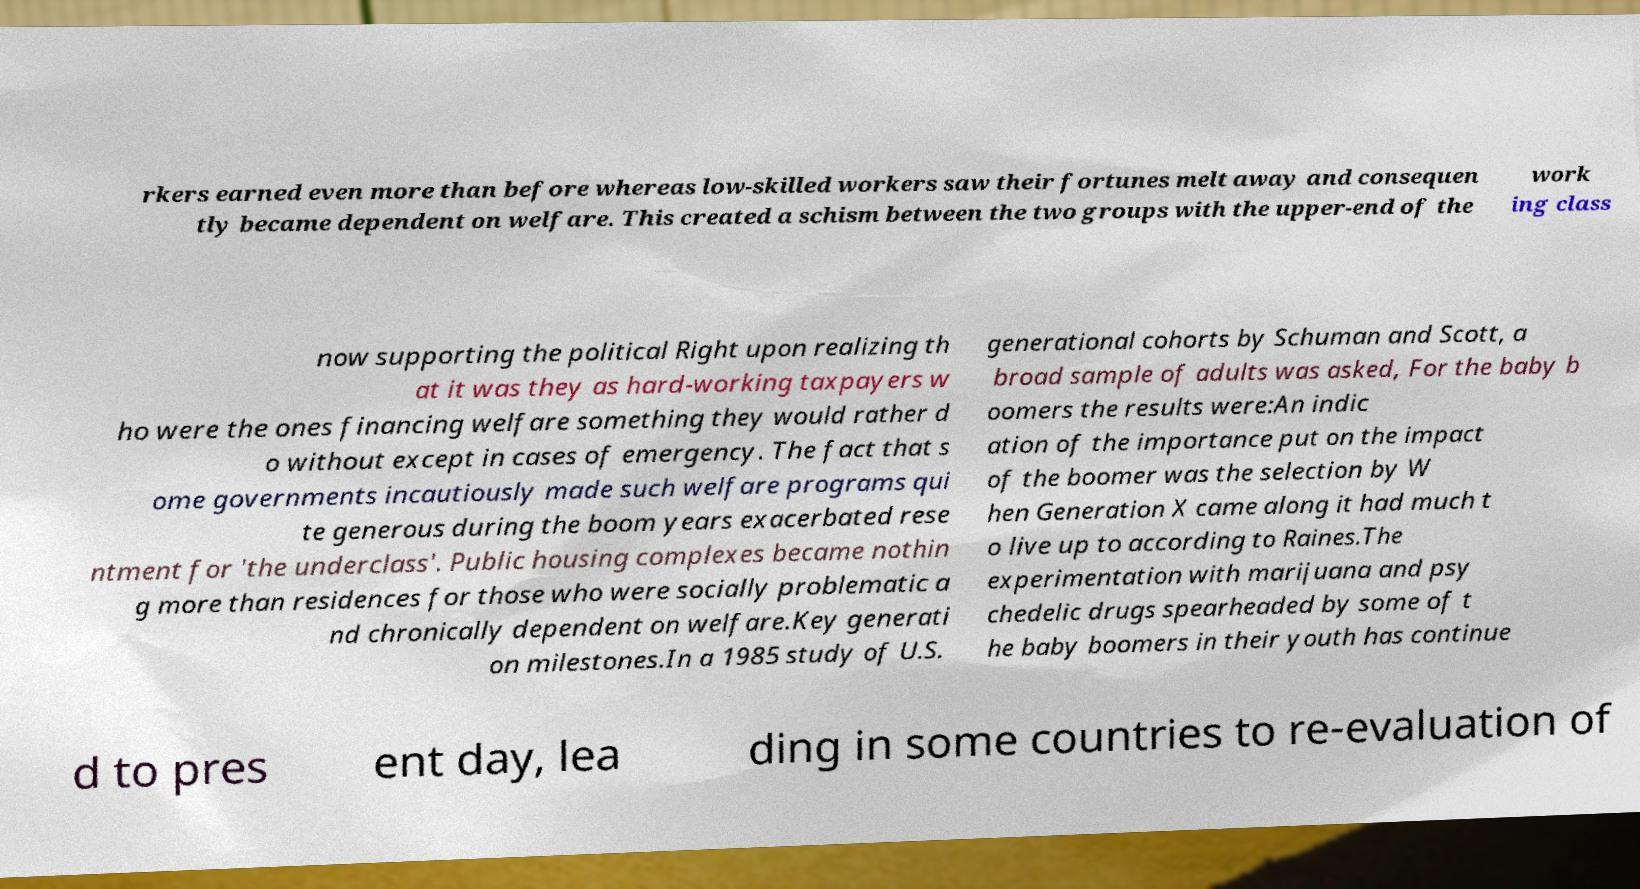For documentation purposes, I need the text within this image transcribed. Could you provide that? rkers earned even more than before whereas low-skilled workers saw their fortunes melt away and consequen tly became dependent on welfare. This created a schism between the two groups with the upper-end of the work ing class now supporting the political Right upon realizing th at it was they as hard-working taxpayers w ho were the ones financing welfare something they would rather d o without except in cases of emergency. The fact that s ome governments incautiously made such welfare programs qui te generous during the boom years exacerbated rese ntment for 'the underclass'. Public housing complexes became nothin g more than residences for those who were socially problematic a nd chronically dependent on welfare.Key generati on milestones.In a 1985 study of U.S. generational cohorts by Schuman and Scott, a broad sample of adults was asked, For the baby b oomers the results were:An indic ation of the importance put on the impact of the boomer was the selection by W hen Generation X came along it had much t o live up to according to Raines.The experimentation with marijuana and psy chedelic drugs spearheaded by some of t he baby boomers in their youth has continue d to pres ent day, lea ding in some countries to re-evaluation of 